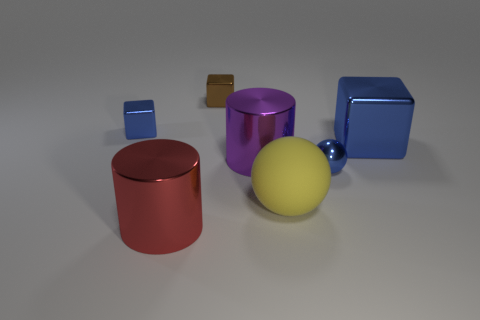There is a metallic object left of the metal object in front of the yellow thing; what is its shape?
Give a very brief answer. Cube. Is the number of blue metallic spheres that are behind the tiny ball less than the number of large matte balls?
Give a very brief answer. Yes. There is a big metal thing that is the same color as the tiny ball; what is its shape?
Keep it short and to the point. Cube. How many purple cylinders have the same size as the yellow thing?
Provide a short and direct response. 1. There is a large metallic thing that is to the right of the purple thing; what shape is it?
Your response must be concise. Cube. Are there fewer tiny blue things than big purple things?
Offer a very short reply. No. Is there anything else of the same color as the large rubber ball?
Provide a succinct answer. No. There is a blue metallic block to the right of the big purple cylinder; what size is it?
Your answer should be compact. Large. Are there more small blue things than small brown things?
Offer a terse response. Yes. What material is the large ball?
Make the answer very short. Rubber. 